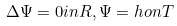<formula> <loc_0><loc_0><loc_500><loc_500>\Delta \Psi = 0 i n R , \Psi = h o n T</formula> 